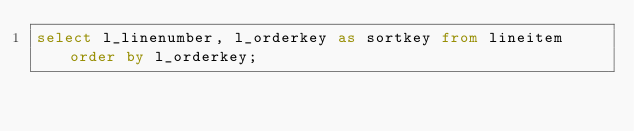Convert code to text. <code><loc_0><loc_0><loc_500><loc_500><_SQL_>select l_linenumber, l_orderkey as sortkey from lineitem order by l_orderkey;</code> 